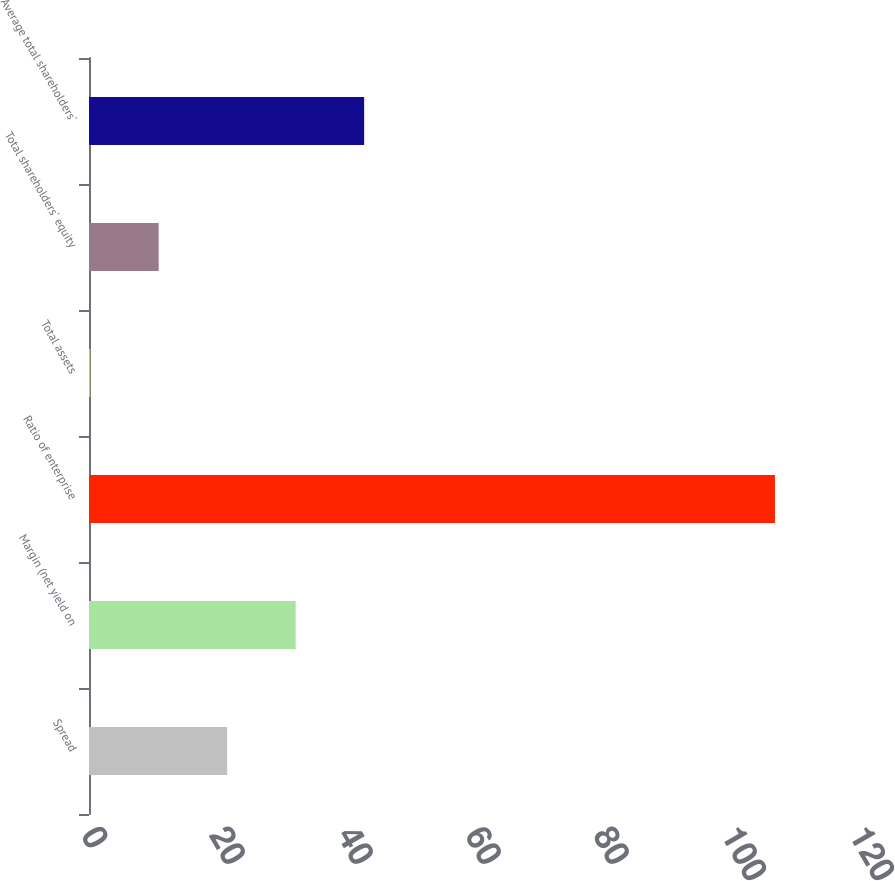<chart> <loc_0><loc_0><loc_500><loc_500><bar_chart><fcel>Spread<fcel>Margin (net yield on<fcel>Ratio of enterprise<fcel>Total assets<fcel>Total shareholders' equity<fcel>Average total shareholders'<nl><fcel>21.59<fcel>32.29<fcel>107.18<fcel>0.19<fcel>10.89<fcel>42.99<nl></chart> 